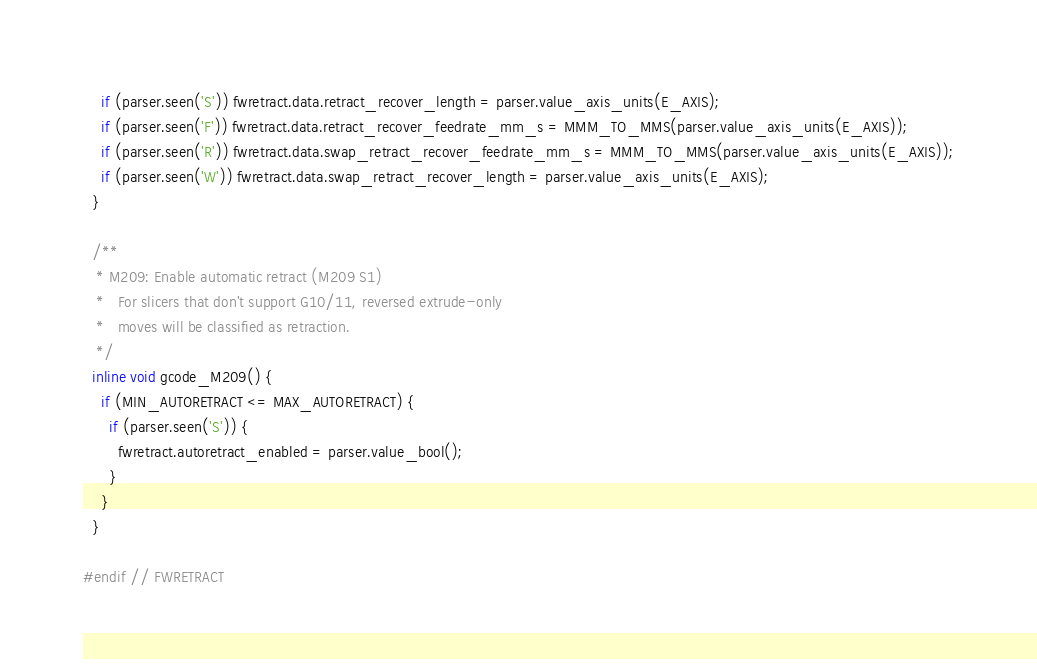<code> <loc_0><loc_0><loc_500><loc_500><_C_>    if (parser.seen('S')) fwretract.data.retract_recover_length = parser.value_axis_units(E_AXIS);
    if (parser.seen('F')) fwretract.data.retract_recover_feedrate_mm_s = MMM_TO_MMS(parser.value_axis_units(E_AXIS));
    if (parser.seen('R')) fwretract.data.swap_retract_recover_feedrate_mm_s = MMM_TO_MMS(parser.value_axis_units(E_AXIS));
    if (parser.seen('W')) fwretract.data.swap_retract_recover_length = parser.value_axis_units(E_AXIS);
  }

  /**
   * M209: Enable automatic retract (M209 S1)
   *   For slicers that don't support G10/11, reversed extrude-only
   *   moves will be classified as retraction.
   */
  inline void gcode_M209() {
    if (MIN_AUTORETRACT <= MAX_AUTORETRACT) {
      if (parser.seen('S')) {
        fwretract.autoretract_enabled = parser.value_bool();
      }
    }
  }

#endif // FWRETRACT
</code> 